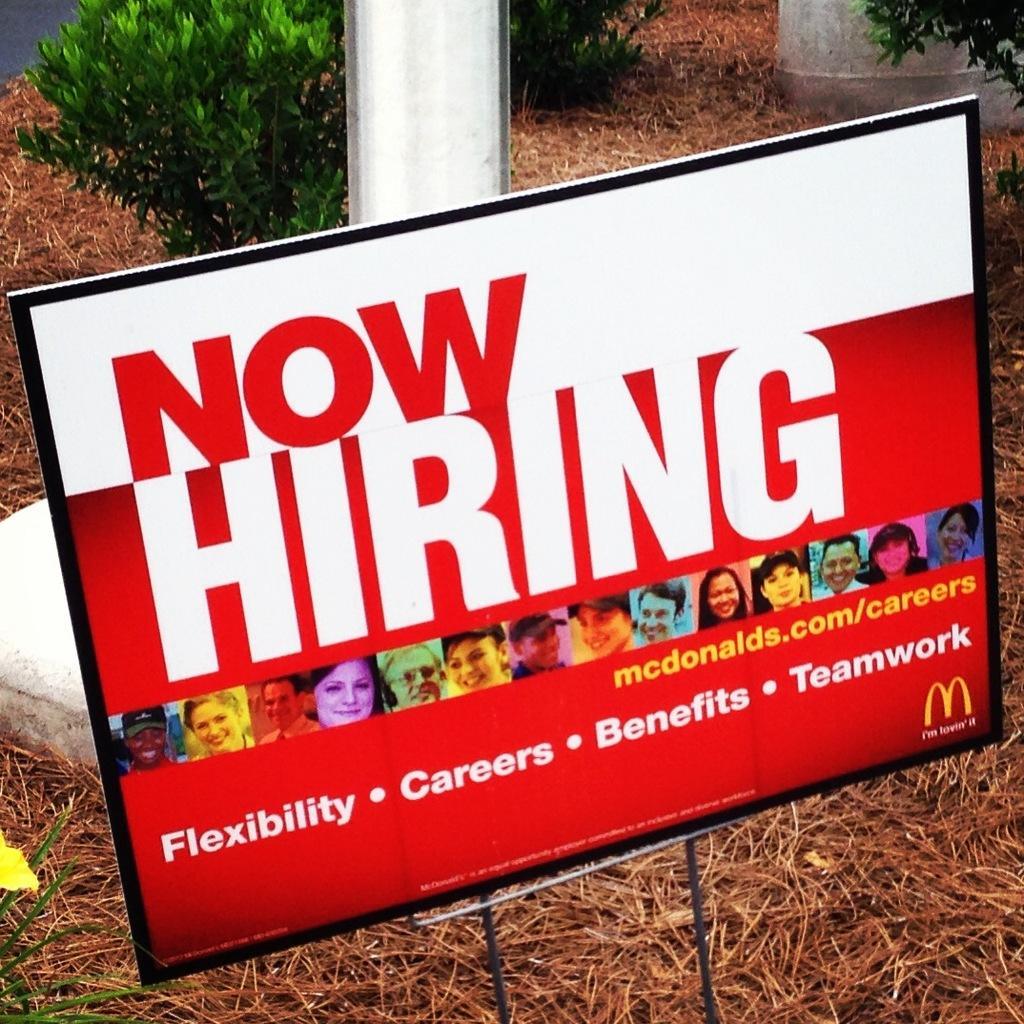Could you give a brief overview of what you see in this image? This image consists of a board. At the bottom, there is dry grass. In the background, there is a pole along with green plants. 